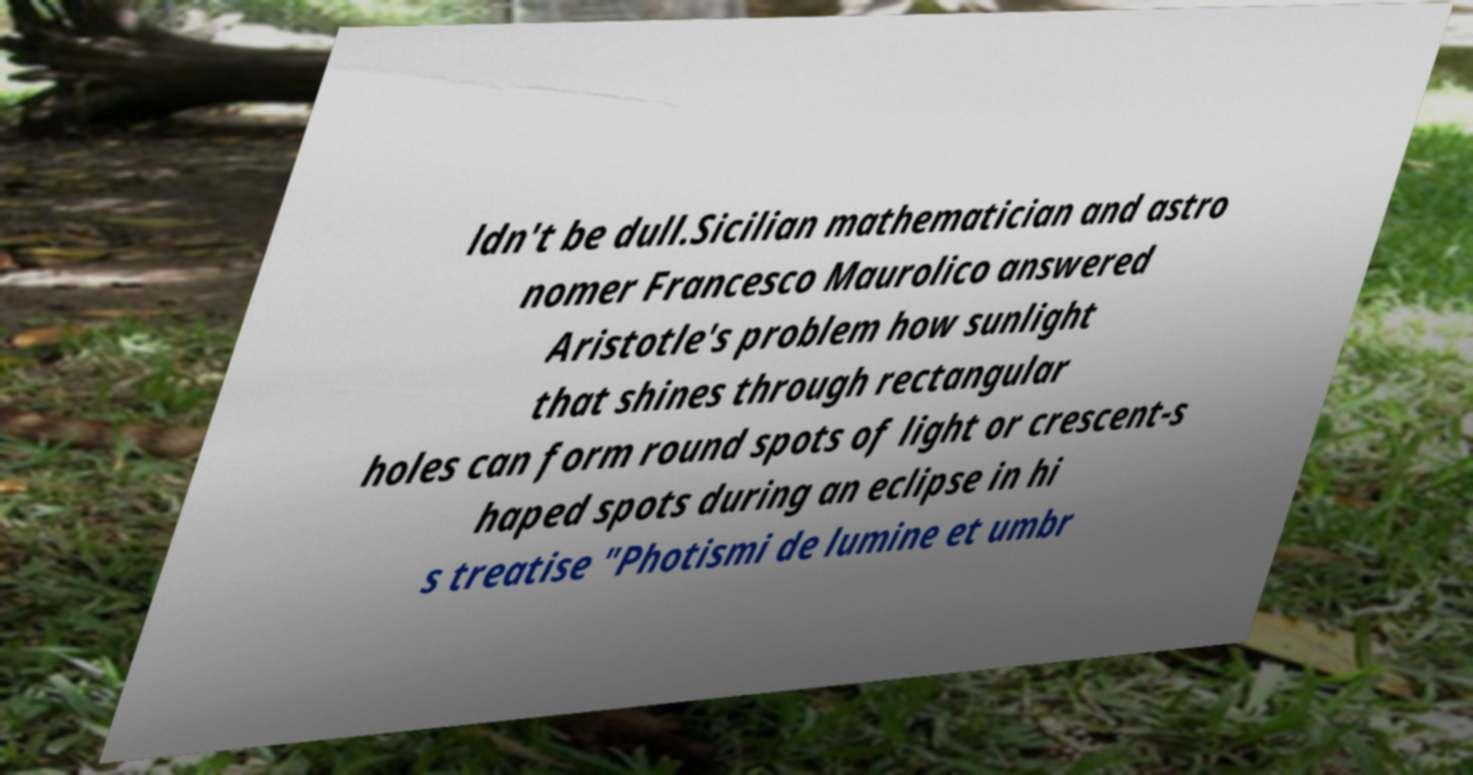Can you accurately transcribe the text from the provided image for me? ldn't be dull.Sicilian mathematician and astro nomer Francesco Maurolico answered Aristotle's problem how sunlight that shines through rectangular holes can form round spots of light or crescent-s haped spots during an eclipse in hi s treatise "Photismi de lumine et umbr 